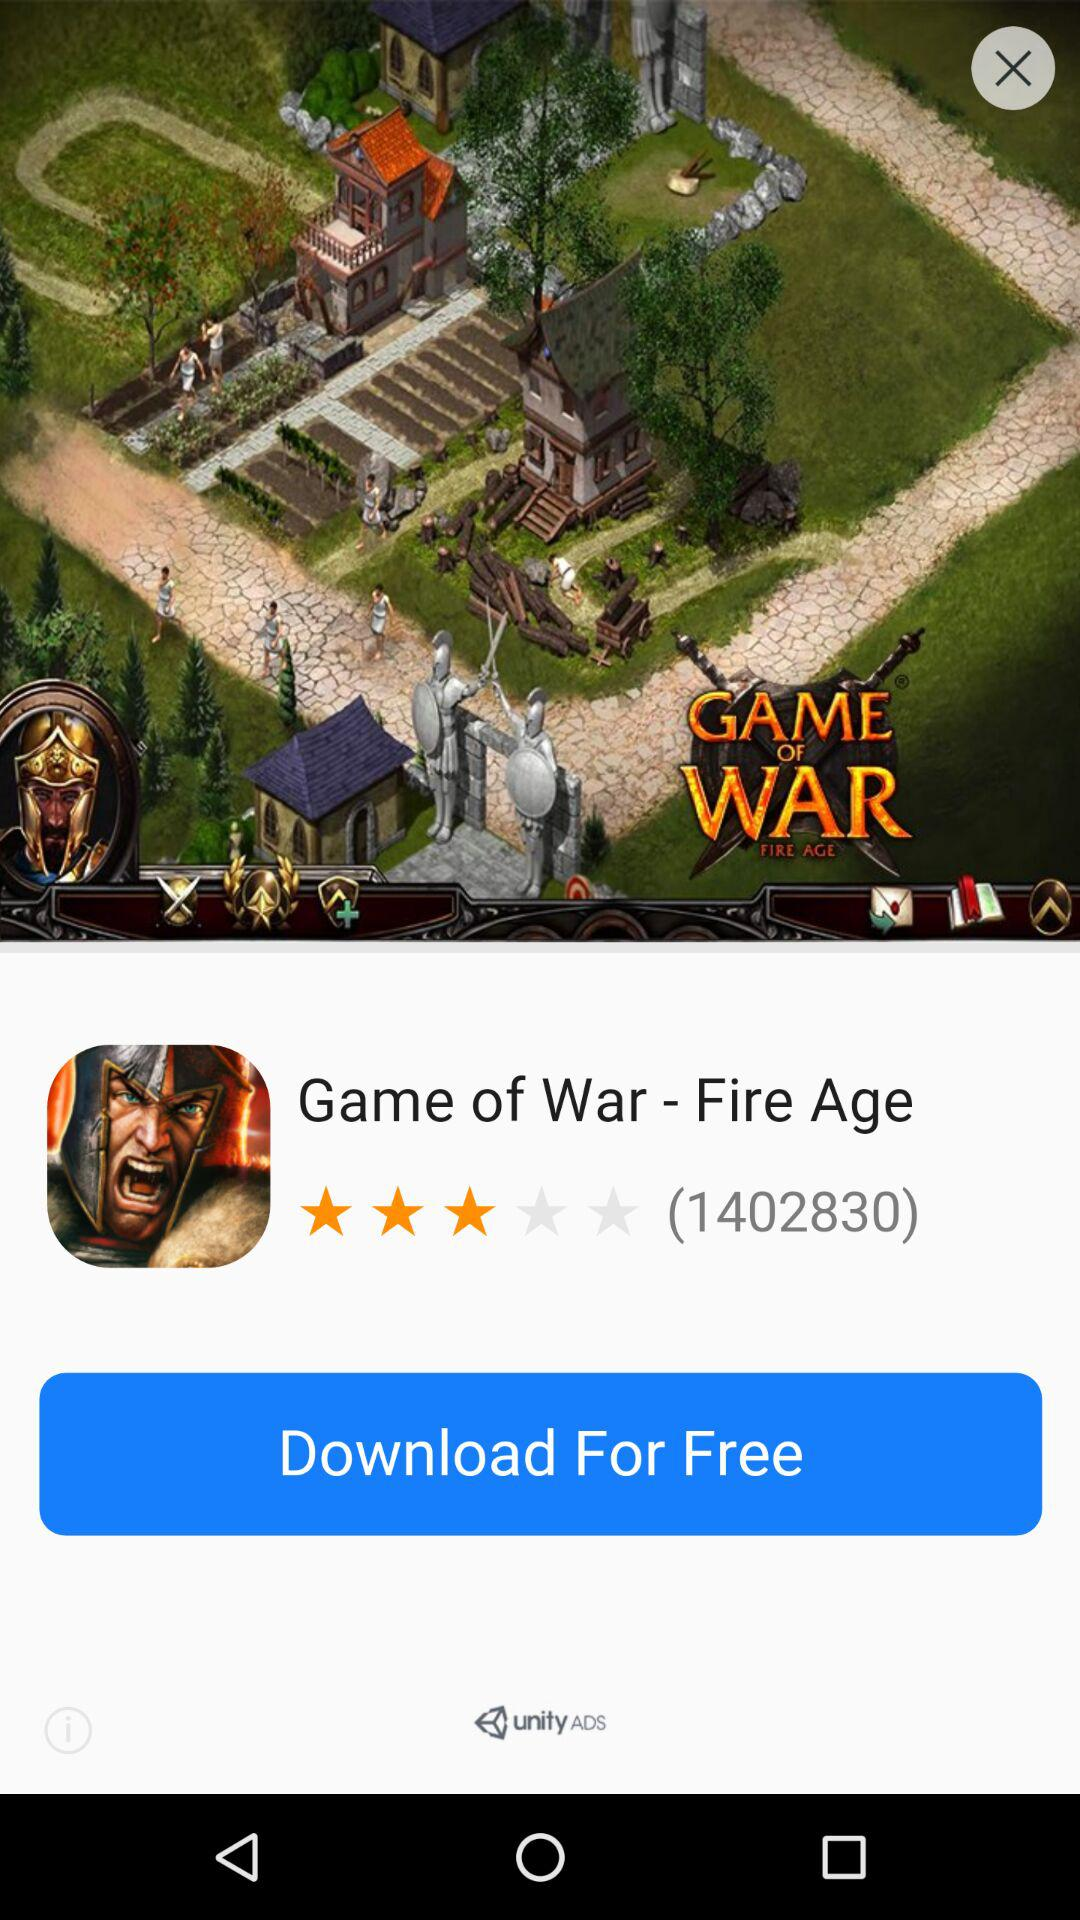What is the name of the game? The name of the game is "Game of War - Fire Age". 